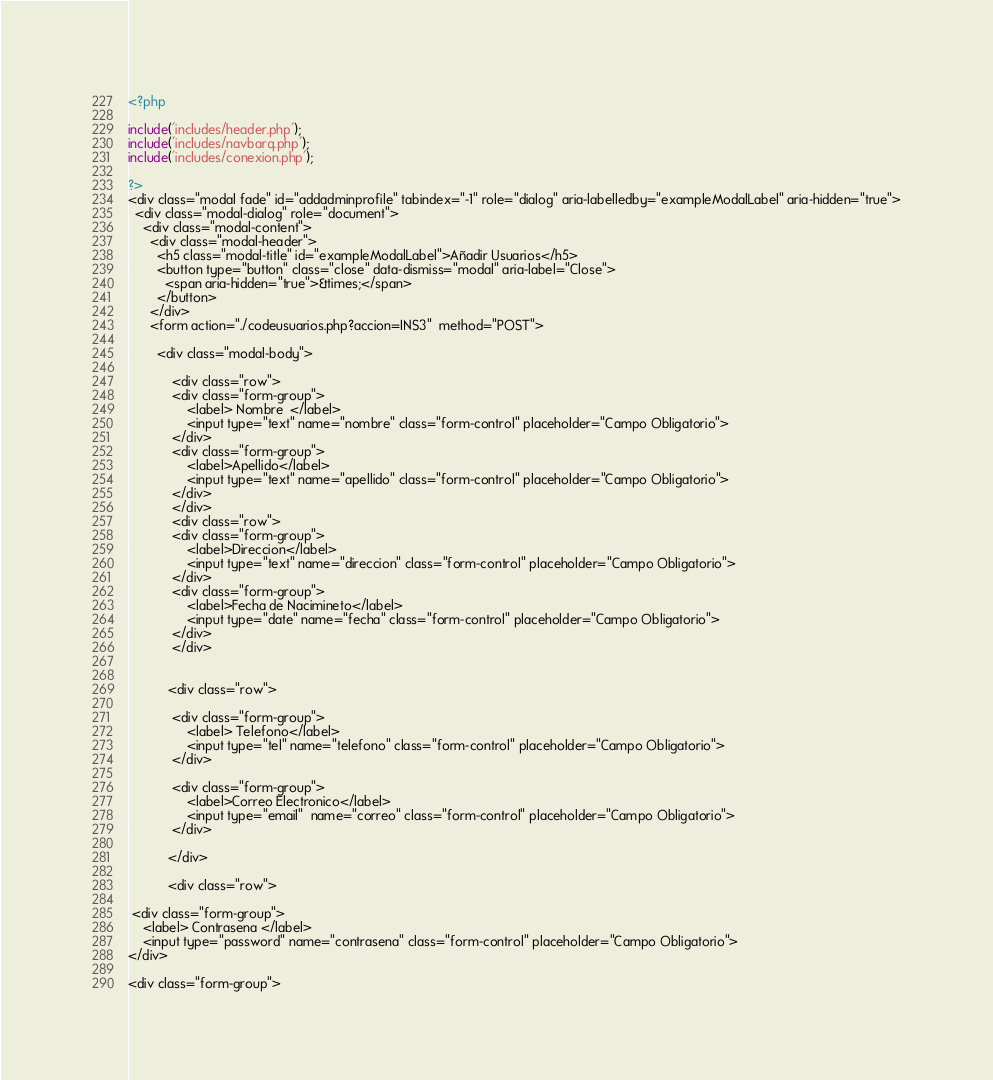<code> <loc_0><loc_0><loc_500><loc_500><_PHP_><?php

include('includes/header.php');
include('includes/navbarq.php');
include('includes/conexion.php');

?>
<div class="modal fade" id="addadminprofile" tabindex="-1" role="dialog" aria-labelledby="exampleModalLabel" aria-hidden="true">
  <div class="modal-dialog" role="document">
    <div class="modal-content">
      <div class="modal-header">
        <h5 class="modal-title" id="exampleModalLabel">Añadir Usuarios</h5>
        <button type="button" class="close" data-dismiss="modal" aria-label="Close">
          <span aria-hidden="true">&times;</span>
        </button>
      </div>
      <form action="./codeusuarios.php?accion=INS3"  method="POST">

        <div class="modal-body">

            <div class="row">
            <div class="form-group">
                <label> Nombre  </label>
                <input type="text" name="nombre" class="form-control" placeholder="Campo Obligatorio">
            </div>
            <div class="form-group">
                <label>Apellido</label>
                <input type="text" name="apellido" class="form-control" placeholder="Campo Obligatorio">
            </div>
            </div>
            <div class="row">
            <div class="form-group">
                <label>Direccion</label>
                <input type="text" name="direccion" class="form-control" placeholder="Campo Obligatorio">
            </div>
            <div class="form-group">
                <label>Fecha de Nacimineto</label>
                <input type="date" name="fecha" class="form-control" placeholder="Campo Obligatorio">
            </div>
            </div>


           <div class="row">

            <div class="form-group">
                <label> Telefono</label>
                <input type="tel" name="telefono" class="form-control" placeholder="Campo Obligatorio">
            </div>

            <div class="form-group">
                <label>Correo Electronico</label>
                <input type="email"  name="correo" class="form-control" placeholder="Campo Obligatorio">
            </div>

           </div>

           <div class="row">

 <div class="form-group">
    <label> Contrasena </label>
    <input type="password" name="contrasena" class="form-control" placeholder="Campo Obligatorio">
</div>

<div class="form-group"></code> 